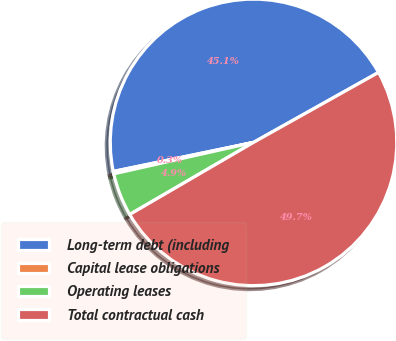Convert chart to OTSL. <chart><loc_0><loc_0><loc_500><loc_500><pie_chart><fcel>Long-term debt (including<fcel>Capital lease obligations<fcel>Operating leases<fcel>Total contractual cash<nl><fcel>45.13%<fcel>0.27%<fcel>4.87%<fcel>49.73%<nl></chart> 